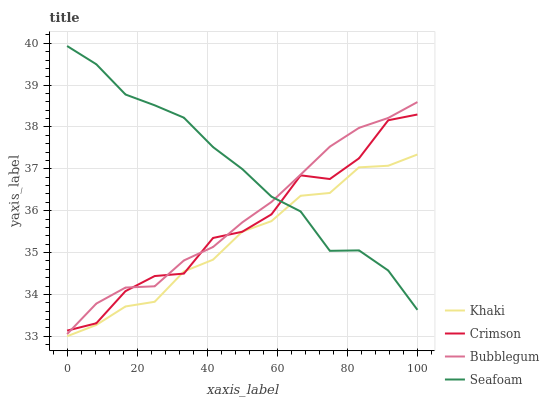Does Khaki have the minimum area under the curve?
Answer yes or no. Yes. Does Seafoam have the maximum area under the curve?
Answer yes or no. Yes. Does Seafoam have the minimum area under the curve?
Answer yes or no. No. Does Khaki have the maximum area under the curve?
Answer yes or no. No. Is Bubblegum the smoothest?
Answer yes or no. Yes. Is Crimson the roughest?
Answer yes or no. Yes. Is Khaki the smoothest?
Answer yes or no. No. Is Khaki the roughest?
Answer yes or no. No. Does Khaki have the lowest value?
Answer yes or no. Yes. Does Seafoam have the lowest value?
Answer yes or no. No. Does Seafoam have the highest value?
Answer yes or no. Yes. Does Khaki have the highest value?
Answer yes or no. No. Is Khaki less than Bubblegum?
Answer yes or no. Yes. Is Bubblegum greater than Khaki?
Answer yes or no. Yes. Does Khaki intersect Crimson?
Answer yes or no. Yes. Is Khaki less than Crimson?
Answer yes or no. No. Is Khaki greater than Crimson?
Answer yes or no. No. Does Khaki intersect Bubblegum?
Answer yes or no. No. 